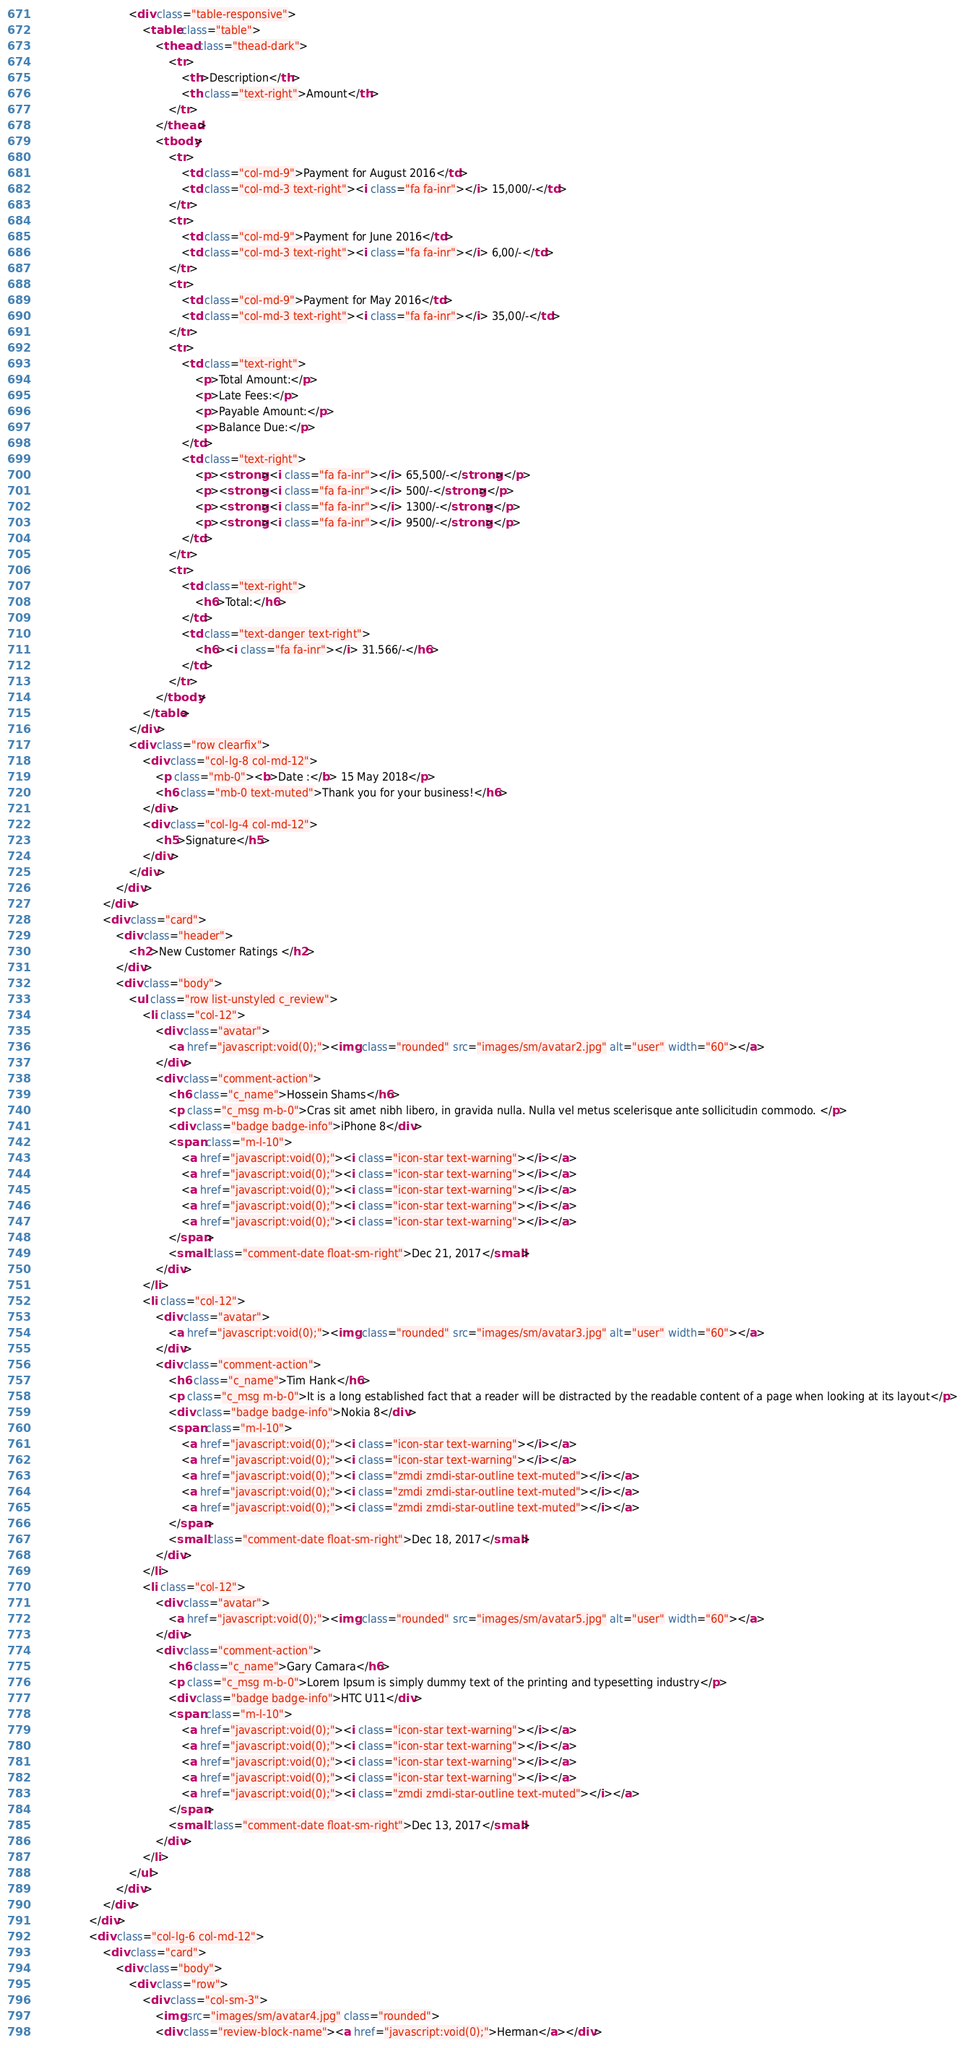Convert code to text. <code><loc_0><loc_0><loc_500><loc_500><_HTML_>                            <div class="table-responsive">
                                <table class="table">
                                    <thead class="thead-dark">
                                        <tr>
                                            <th>Description</th>
                                            <th class="text-right">Amount</th>
                                        </tr>
                                    </thead>
                                    <tbody>
                                        <tr>
                                            <td class="col-md-9">Payment for August 2016</td>
                                            <td class="col-md-3 text-right"><i class="fa fa-inr"></i> 15,000/-</td>
                                        </tr>
                                        <tr>
                                            <td class="col-md-9">Payment for June 2016</td>
                                            <td class="col-md-3 text-right"><i class="fa fa-inr"></i> 6,00/-</td>
                                        </tr>
                                        <tr>
                                            <td class="col-md-9">Payment for May 2016</td>
                                            <td class="col-md-3 text-right"><i class="fa fa-inr"></i> 35,00/-</td>
                                        </tr>
                                        <tr>
                                            <td class="text-right">
                                                <p>Total Amount:</p>
                                                <p>Late Fees:</p>
                                                <p>Payable Amount:</p>
                                                <p>Balance Due:</p>
                                            </td>
                                            <td class="text-right">
                                                <p><strong><i class="fa fa-inr"></i> 65,500/-</strong></p>
                                                <p><strong><i class="fa fa-inr"></i> 500/-</strong></p>
                                                <p><strong><i class="fa fa-inr"></i> 1300/-</strong></p>
                                                <p><strong><i class="fa fa-inr"></i> 9500/-</strong></p>
                                            </td>
                                        </tr>
                                        <tr>
                                            <td class="text-right">
                                                <h6>Total:</h6>
                                            </td>
                                            <td class="text-danger text-right">
                                                <h6><i class="fa fa-inr"></i> 31.566/-</h6>
                                            </td>
                                        </tr>
                                    </tbody>
                                </table>
                            </div>                    
                            <div class="row clearfix">
                                <div class="col-lg-8 col-md-12">
                                    <p class="mb-0"><b>Date :</b> 15 May 2018</p>
                                    <h6 class="mb-0 text-muted">Thank you for your business!</h6>
                                </div>
                                <div class="col-lg-4 col-md-12">
                                    <h5>Signature</h5>
                                </div>
                            </div>
                        </div>
                    </div>
                    <div class="card">
                        <div class="header">
                            <h2>New Customer Ratings </h2>
                        </div>
                        <div class="body">
                            <ul class="row list-unstyled c_review">
                                <li class="col-12">
                                    <div class="avatar">
                                        <a href="javascript:void(0);"><img class="rounded" src="images/sm/avatar2.jpg" alt="user" width="60"></a>
                                    </div>                                
                                    <div class="comment-action">
                                        <h6 class="c_name">Hossein Shams</h6>
                                        <p class="c_msg m-b-0">Cras sit amet nibh libero, in gravida nulla. Nulla vel metus scelerisque ante sollicitudin commodo. </p>
                                        <div class="badge badge-info">iPhone 8</div>
                                        <span class="m-l-10">
                                            <a href="javascript:void(0);"><i class="icon-star text-warning"></i></a>
                                            <a href="javascript:void(0);"><i class="icon-star text-warning"></i></a>
                                            <a href="javascript:void(0);"><i class="icon-star text-warning"></i></a>
                                            <a href="javascript:void(0);"><i class="icon-star text-warning"></i></a>
                                            <a href="javascript:void(0);"><i class="icon-star text-warning"></i></a>
                                        </span>
                                        <small class="comment-date float-sm-right">Dec 21, 2017</small>
                                    </div>                                
                                </li>
                                <li class="col-12">
                                    <div class="avatar">
                                        <a href="javascript:void(0);"><img class="rounded" src="images/sm/avatar3.jpg" alt="user" width="60"></a>
                                    </div>                                
                                    <div class="comment-action">
                                        <h6 class="c_name">Tim Hank</h6>
                                        <p class="c_msg m-b-0">It is a long established fact that a reader will be distracted by the readable content of a page when looking at its layout</p>
                                        <div class="badge badge-info">Nokia 8</div>
                                        <span class="m-l-10">
                                            <a href="javascript:void(0);"><i class="icon-star text-warning"></i></a>
                                            <a href="javascript:void(0);"><i class="icon-star text-warning"></i></a>
                                            <a href="javascript:void(0);"><i class="zmdi zmdi-star-outline text-muted"></i></a>
                                            <a href="javascript:void(0);"><i class="zmdi zmdi-star-outline text-muted"></i></a>
                                            <a href="javascript:void(0);"><i class="zmdi zmdi-star-outline text-muted"></i></a>
                                        </span>
                                        <small class="comment-date float-sm-right">Dec 18, 2017</small>
                                    </div>                                
                                </li>
                                <li class="col-12">
                                    <div class="avatar">
                                        <a href="javascript:void(0);"><img class="rounded" src="images/sm/avatar5.jpg" alt="user" width="60"></a>
                                    </div>                                
                                    <div class="comment-action">
                                        <h6 class="c_name">Gary Camara</h6>
                                        <p class="c_msg m-b-0">Lorem Ipsum is simply dummy text of the printing and typesetting industry</p>
                                        <div class="badge badge-info">HTC U11</div>
                                        <span class="m-l-10">
                                            <a href="javascript:void(0);"><i class="icon-star text-warning"></i></a>
                                            <a href="javascript:void(0);"><i class="icon-star text-warning"></i></a>
                                            <a href="javascript:void(0);"><i class="icon-star text-warning"></i></a>
                                            <a href="javascript:void(0);"><i class="icon-star text-warning"></i></a>
                                            <a href="javascript:void(0);"><i class="zmdi zmdi-star-outline text-muted"></i></a>
                                        </span>
                                        <small class="comment-date float-sm-right">Dec 13, 2017</small>
                                    </div>                                
                                </li>
                            </ul>
                        </div>
                    </div>
                </div>
                <div class="col-lg-6 col-md-12">
                    <div class="card">
                        <div class="body">
                            <div class="row">
                                <div class="col-sm-3">
                                    <img src="images/sm/avatar4.jpg" class="rounded">
                                    <div class="review-block-name"><a href="javascript:void(0);">Herman</a></div></code> 